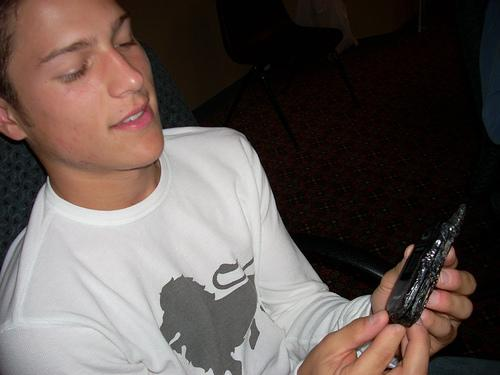Describe a small but significant detail of the boy's attire. The collar of the boy's white shirt is quite visible, with its seams and edges neatly finished. Narrate the image by focussing on the boy's expression and his feelings about the phone. The boy's furrowed eyebrows and focused gaze on the melted phone suggest that he is puzzled and upset by the device's condition. Mention a distinctive feature of the boy's clothing in the image. The boy's white long-sleeved t-shirt has a unique gray lion design on it. Explain what the boy is holding and its condition. The boy is holding a melted phone in his hands, which looks damaged beyond repair. Comment on the boy's activity related to the object he's holding. The boy appears to be examining the melted phone in his hands with a mix of curiosity and concern. Briefly mention the context in which the boy is sitting and holding an object. The boy is sitting on a dark chair with a dark patterned floor beneath him, holding a damaged phone. Provide a brief summary of the scene in the image. A boy is looking down at a melted phone he's holding, wearing a white shirt with a gray lion design and sitting on a black chair with a mysterious arm nearby. Mention the furniture and its location in the image. There's a black chair placed in the dark corner of the room, partially illuminated by light falling on it from the side. In a single sentence, identify and describe the two most prominent elements in the image. The boy wearing a lion-decorated shirt is sitting on a black chair and scrutinizing a melted phone in his hands. 